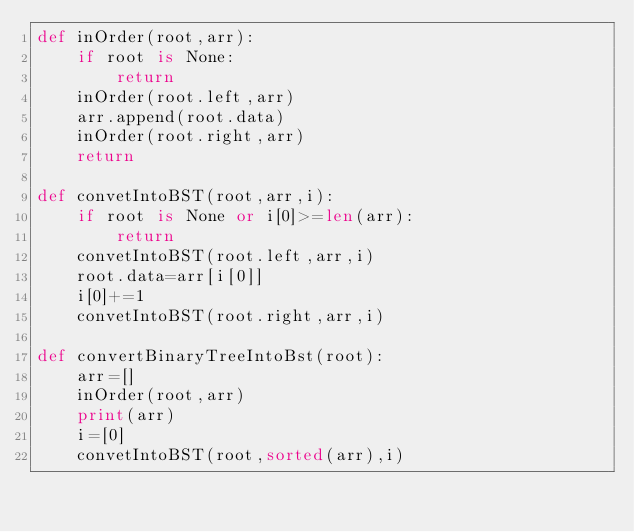<code> <loc_0><loc_0><loc_500><loc_500><_Python_>def inOrder(root,arr):
    if root is None:
        return
    inOrder(root.left,arr)
    arr.append(root.data)
    inOrder(root.right,arr)
    return

def convetIntoBST(root,arr,i):
    if root is None or i[0]>=len(arr):
        return
    convetIntoBST(root.left,arr,i)
    root.data=arr[i[0]]
    i[0]+=1
    convetIntoBST(root.right,arr,i)

def convertBinaryTreeIntoBst(root):
    arr=[]
    inOrder(root,arr)
    print(arr)
    i=[0]
    convetIntoBST(root,sorted(arr),i)

</code> 